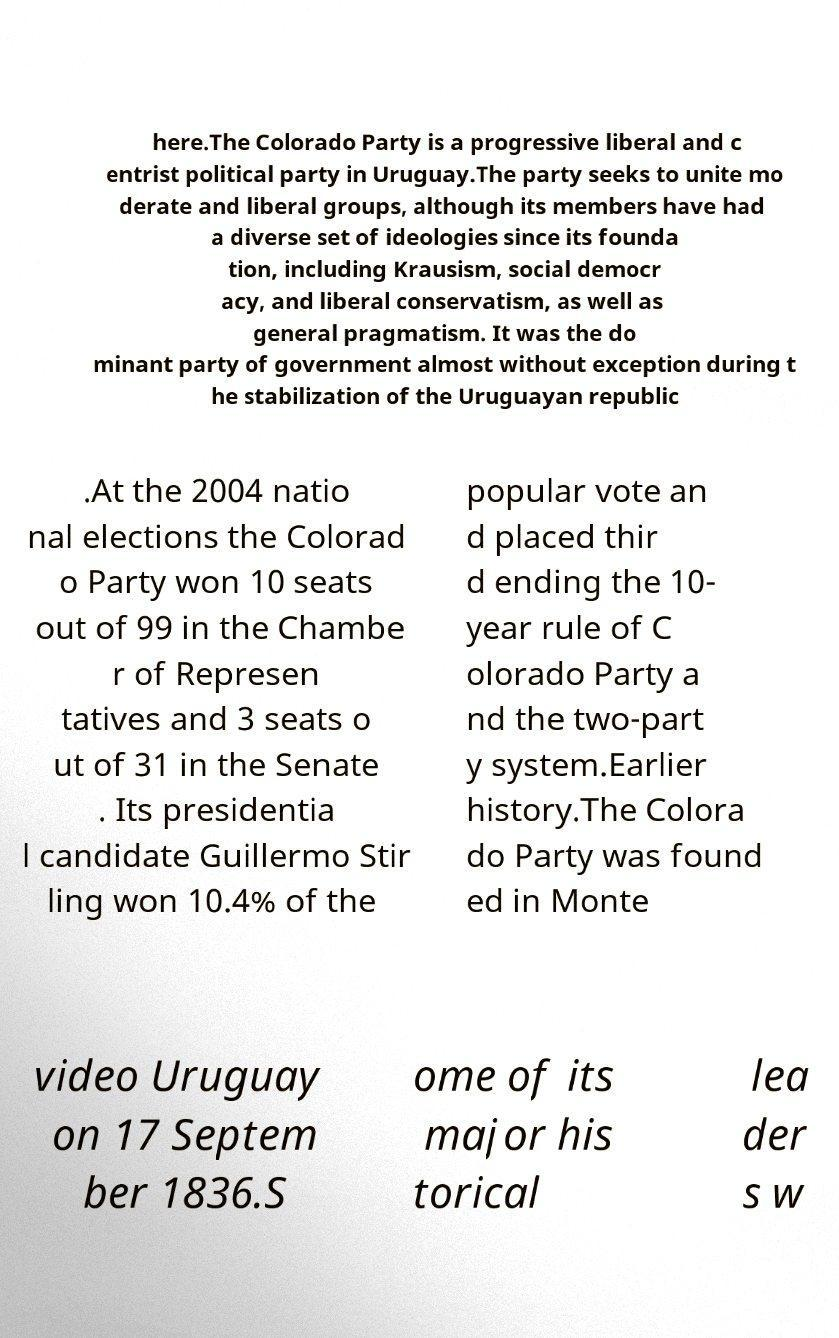What messages or text are displayed in this image? I need them in a readable, typed format. here.The Colorado Party is a progressive liberal and c entrist political party in Uruguay.The party seeks to unite mo derate and liberal groups, although its members have had a diverse set of ideologies since its founda tion, including Krausism, social democr acy, and liberal conservatism, as well as general pragmatism. It was the do minant party of government almost without exception during t he stabilization of the Uruguayan republic .At the 2004 natio nal elections the Colorad o Party won 10 seats out of 99 in the Chambe r of Represen tatives and 3 seats o ut of 31 in the Senate . Its presidentia l candidate Guillermo Stir ling won 10.4% of the popular vote an d placed thir d ending the 10- year rule of C olorado Party a nd the two-part y system.Earlier history.The Colora do Party was found ed in Monte video Uruguay on 17 Septem ber 1836.S ome of its major his torical lea der s w 